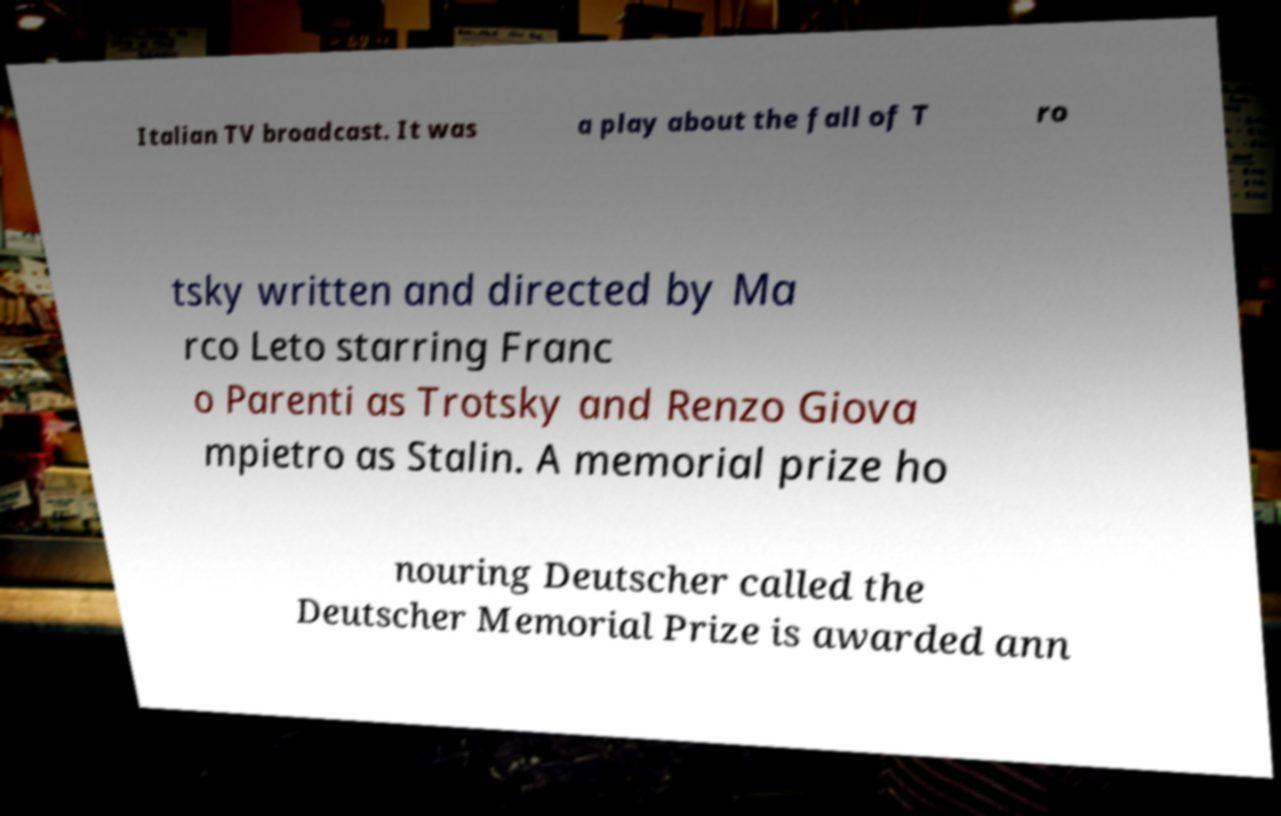Can you accurately transcribe the text from the provided image for me? Italian TV broadcast. It was a play about the fall of T ro tsky written and directed by Ma rco Leto starring Franc o Parenti as Trotsky and Renzo Giova mpietro as Stalin. A memorial prize ho nouring Deutscher called the Deutscher Memorial Prize is awarded ann 